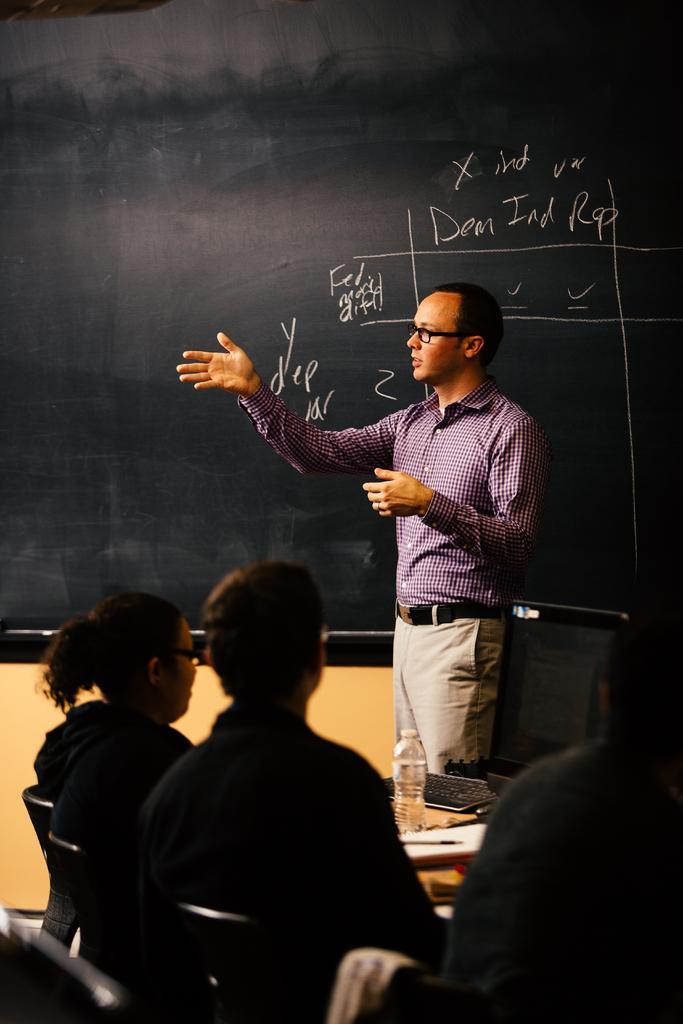Please provide a concise description of this image. In this image we can see a man is standing. Behind the man, we can see the black color board. At the bottom of the image, we can see people are sitting on the black color chairs. In front of the people, we can see a monitor, keyboard, paper, pen and bottle. 